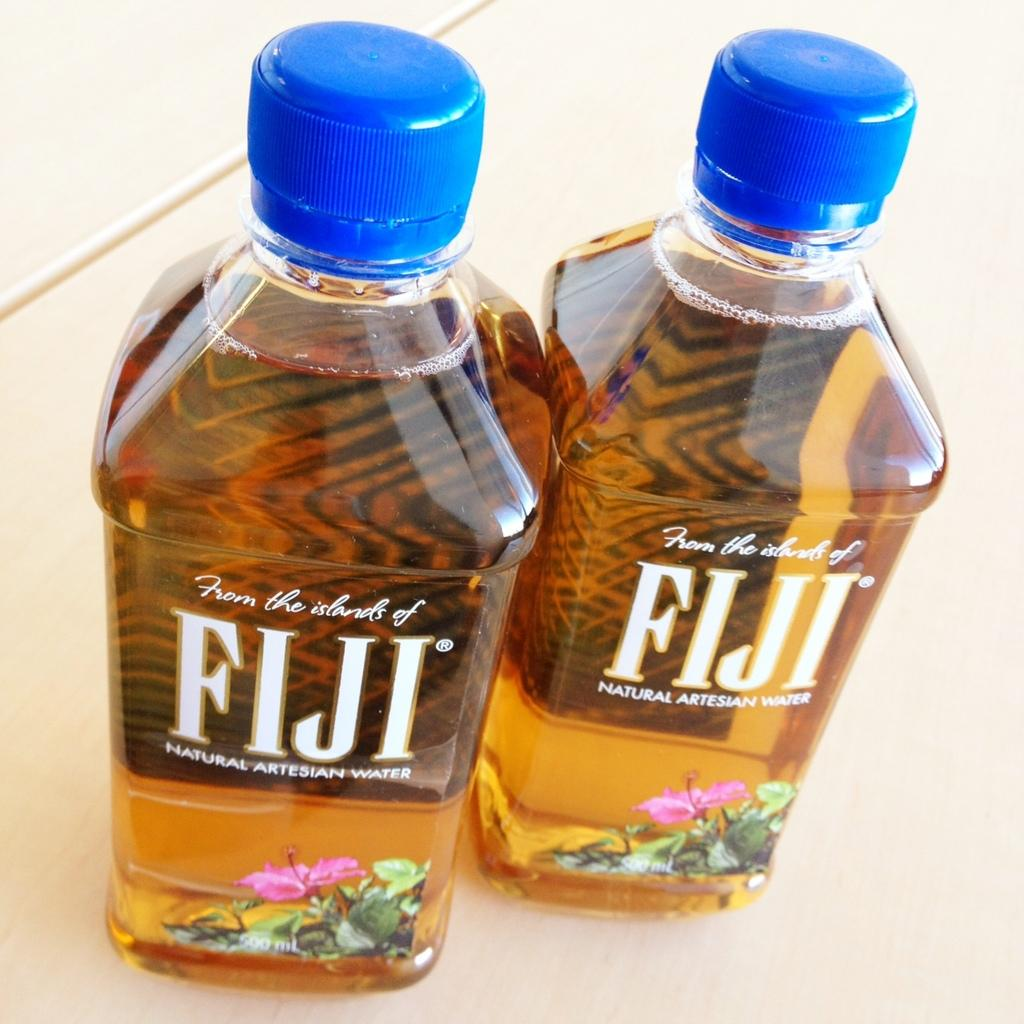<image>
Share a concise interpretation of the image provided. FIJI water bottles claiming to be from the islands of Fiji. 